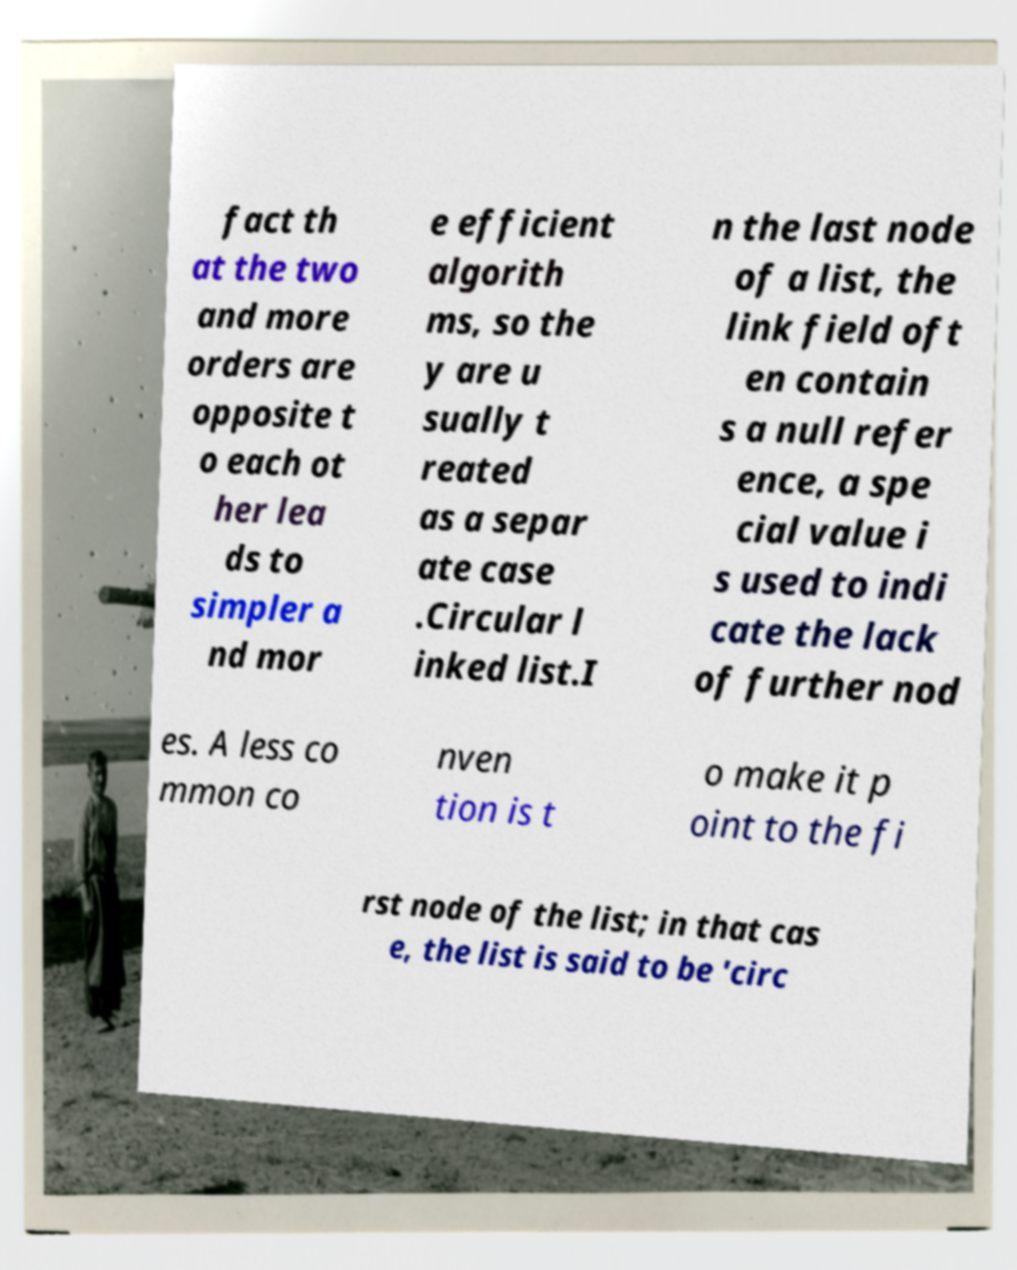For documentation purposes, I need the text within this image transcribed. Could you provide that? fact th at the two and more orders are opposite t o each ot her lea ds to simpler a nd mor e efficient algorith ms, so the y are u sually t reated as a separ ate case .Circular l inked list.I n the last node of a list, the link field oft en contain s a null refer ence, a spe cial value i s used to indi cate the lack of further nod es. A less co mmon co nven tion is t o make it p oint to the fi rst node of the list; in that cas e, the list is said to be 'circ 